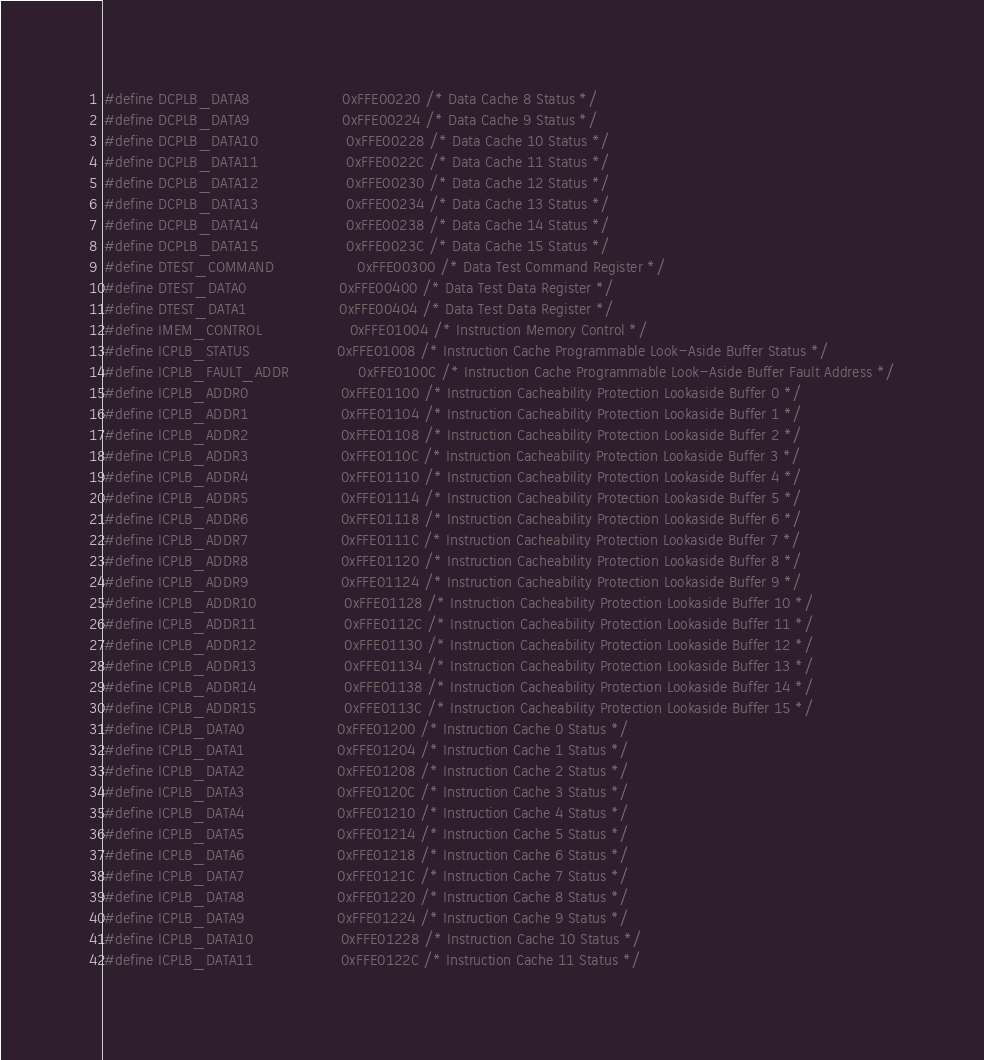<code> <loc_0><loc_0><loc_500><loc_500><_C_>#define DCPLB_DATA8                    0xFFE00220 /* Data Cache 8 Status */
#define DCPLB_DATA9                    0xFFE00224 /* Data Cache 9 Status */
#define DCPLB_DATA10                   0xFFE00228 /* Data Cache 10 Status */
#define DCPLB_DATA11                   0xFFE0022C /* Data Cache 11 Status */
#define DCPLB_DATA12                   0xFFE00230 /* Data Cache 12 Status */
#define DCPLB_DATA13                   0xFFE00234 /* Data Cache 13 Status */
#define DCPLB_DATA14                   0xFFE00238 /* Data Cache 14 Status */
#define DCPLB_DATA15                   0xFFE0023C /* Data Cache 15 Status */
#define DTEST_COMMAND                  0xFFE00300 /* Data Test Command Register */
#define DTEST_DATA0                    0xFFE00400 /* Data Test Data Register */
#define DTEST_DATA1                    0xFFE00404 /* Data Test Data Register */
#define IMEM_CONTROL                   0xFFE01004 /* Instruction Memory Control */
#define ICPLB_STATUS                   0xFFE01008 /* Instruction Cache Programmable Look-Aside Buffer Status */
#define ICPLB_FAULT_ADDR               0xFFE0100C /* Instruction Cache Programmable Look-Aside Buffer Fault Address */
#define ICPLB_ADDR0                    0xFFE01100 /* Instruction Cacheability Protection Lookaside Buffer 0 */
#define ICPLB_ADDR1                    0xFFE01104 /* Instruction Cacheability Protection Lookaside Buffer 1 */
#define ICPLB_ADDR2                    0xFFE01108 /* Instruction Cacheability Protection Lookaside Buffer 2 */
#define ICPLB_ADDR3                    0xFFE0110C /* Instruction Cacheability Protection Lookaside Buffer 3 */
#define ICPLB_ADDR4                    0xFFE01110 /* Instruction Cacheability Protection Lookaside Buffer 4 */
#define ICPLB_ADDR5                    0xFFE01114 /* Instruction Cacheability Protection Lookaside Buffer 5 */
#define ICPLB_ADDR6                    0xFFE01118 /* Instruction Cacheability Protection Lookaside Buffer 6 */
#define ICPLB_ADDR7                    0xFFE0111C /* Instruction Cacheability Protection Lookaside Buffer 7 */
#define ICPLB_ADDR8                    0xFFE01120 /* Instruction Cacheability Protection Lookaside Buffer 8 */
#define ICPLB_ADDR9                    0xFFE01124 /* Instruction Cacheability Protection Lookaside Buffer 9 */
#define ICPLB_ADDR10                   0xFFE01128 /* Instruction Cacheability Protection Lookaside Buffer 10 */
#define ICPLB_ADDR11                   0xFFE0112C /* Instruction Cacheability Protection Lookaside Buffer 11 */
#define ICPLB_ADDR12                   0xFFE01130 /* Instruction Cacheability Protection Lookaside Buffer 12 */
#define ICPLB_ADDR13                   0xFFE01134 /* Instruction Cacheability Protection Lookaside Buffer 13 */
#define ICPLB_ADDR14                   0xFFE01138 /* Instruction Cacheability Protection Lookaside Buffer 14 */
#define ICPLB_ADDR15                   0xFFE0113C /* Instruction Cacheability Protection Lookaside Buffer 15 */
#define ICPLB_DATA0                    0xFFE01200 /* Instruction Cache 0 Status */
#define ICPLB_DATA1                    0xFFE01204 /* Instruction Cache 1 Status */
#define ICPLB_DATA2                    0xFFE01208 /* Instruction Cache 2 Status */
#define ICPLB_DATA3                    0xFFE0120C /* Instruction Cache 3 Status */
#define ICPLB_DATA4                    0xFFE01210 /* Instruction Cache 4 Status */
#define ICPLB_DATA5                    0xFFE01214 /* Instruction Cache 5 Status */
#define ICPLB_DATA6                    0xFFE01218 /* Instruction Cache 6 Status */
#define ICPLB_DATA7                    0xFFE0121C /* Instruction Cache 7 Status */
#define ICPLB_DATA8                    0xFFE01220 /* Instruction Cache 8 Status */
#define ICPLB_DATA9                    0xFFE01224 /* Instruction Cache 9 Status */
#define ICPLB_DATA10                   0xFFE01228 /* Instruction Cache 10 Status */
#define ICPLB_DATA11                   0xFFE0122C /* Instruction Cache 11 Status */</code> 